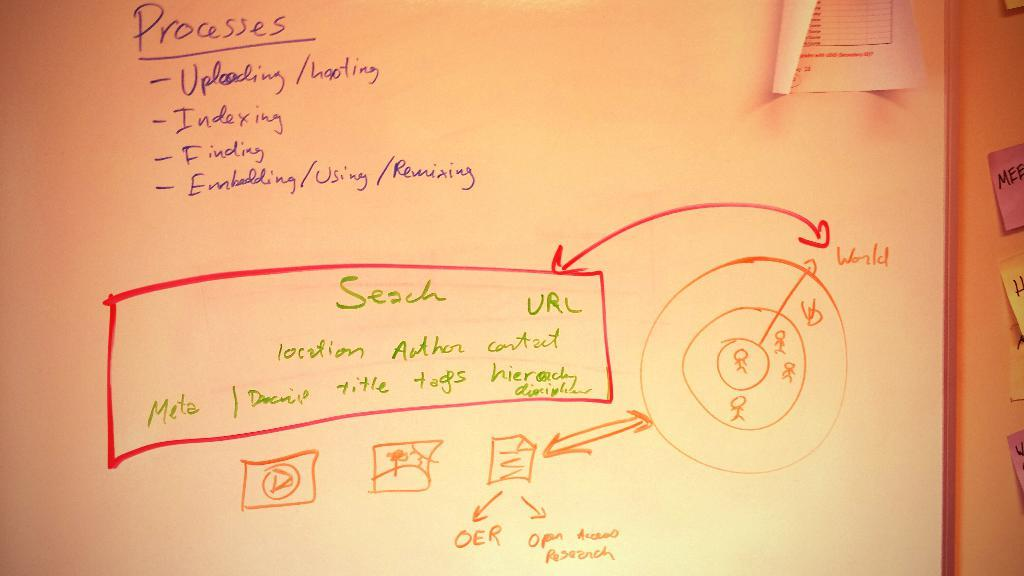What is the main object in the image with text on it? There is a board with text in the image. Are there any other objects with text in the image? Yes, there are papers with text attached to the wall in the image. What news is being reported in the caption of the image? There is no caption present in the image, as the facts only mention a board with text and papers with text attached to the wall. 